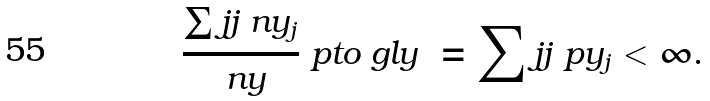<formula> <loc_0><loc_0><loc_500><loc_500>\frac { \sum j j \ n y _ { j } } { \ n y } \ p t o \ g l y \ = \sum j j \ p y _ { j } < \infty .</formula> 